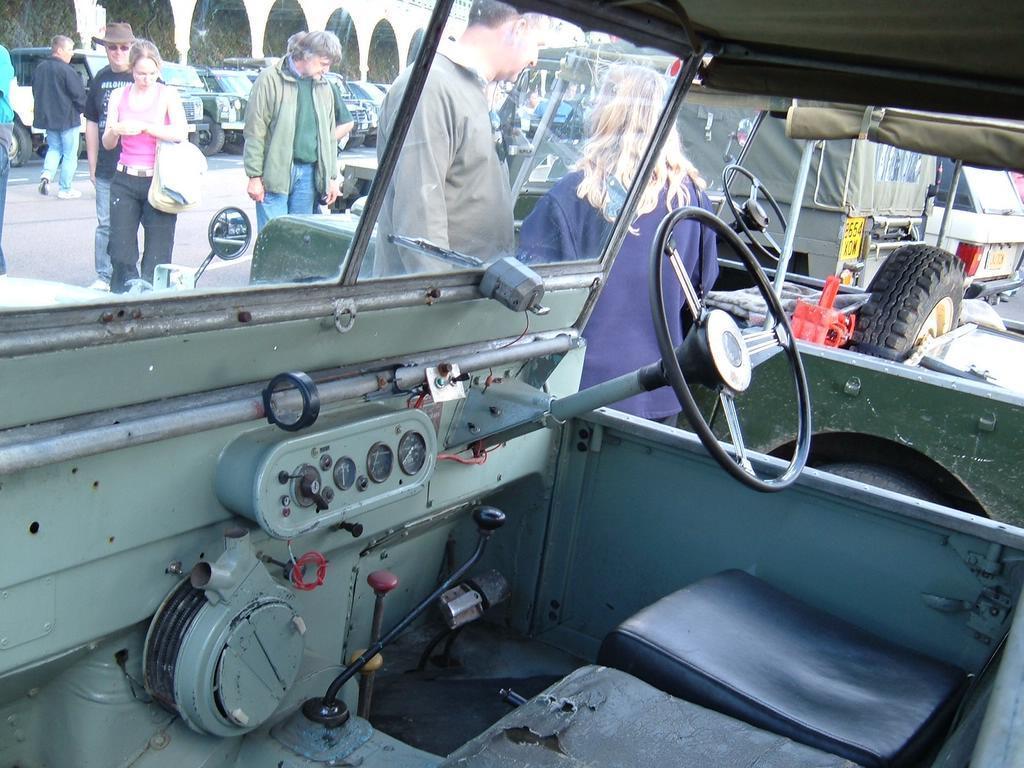In one or two sentences, can you explain what this image depicts? This image is clicked from inside a car, in the there are many people walking on the road with cars on either side of it. 